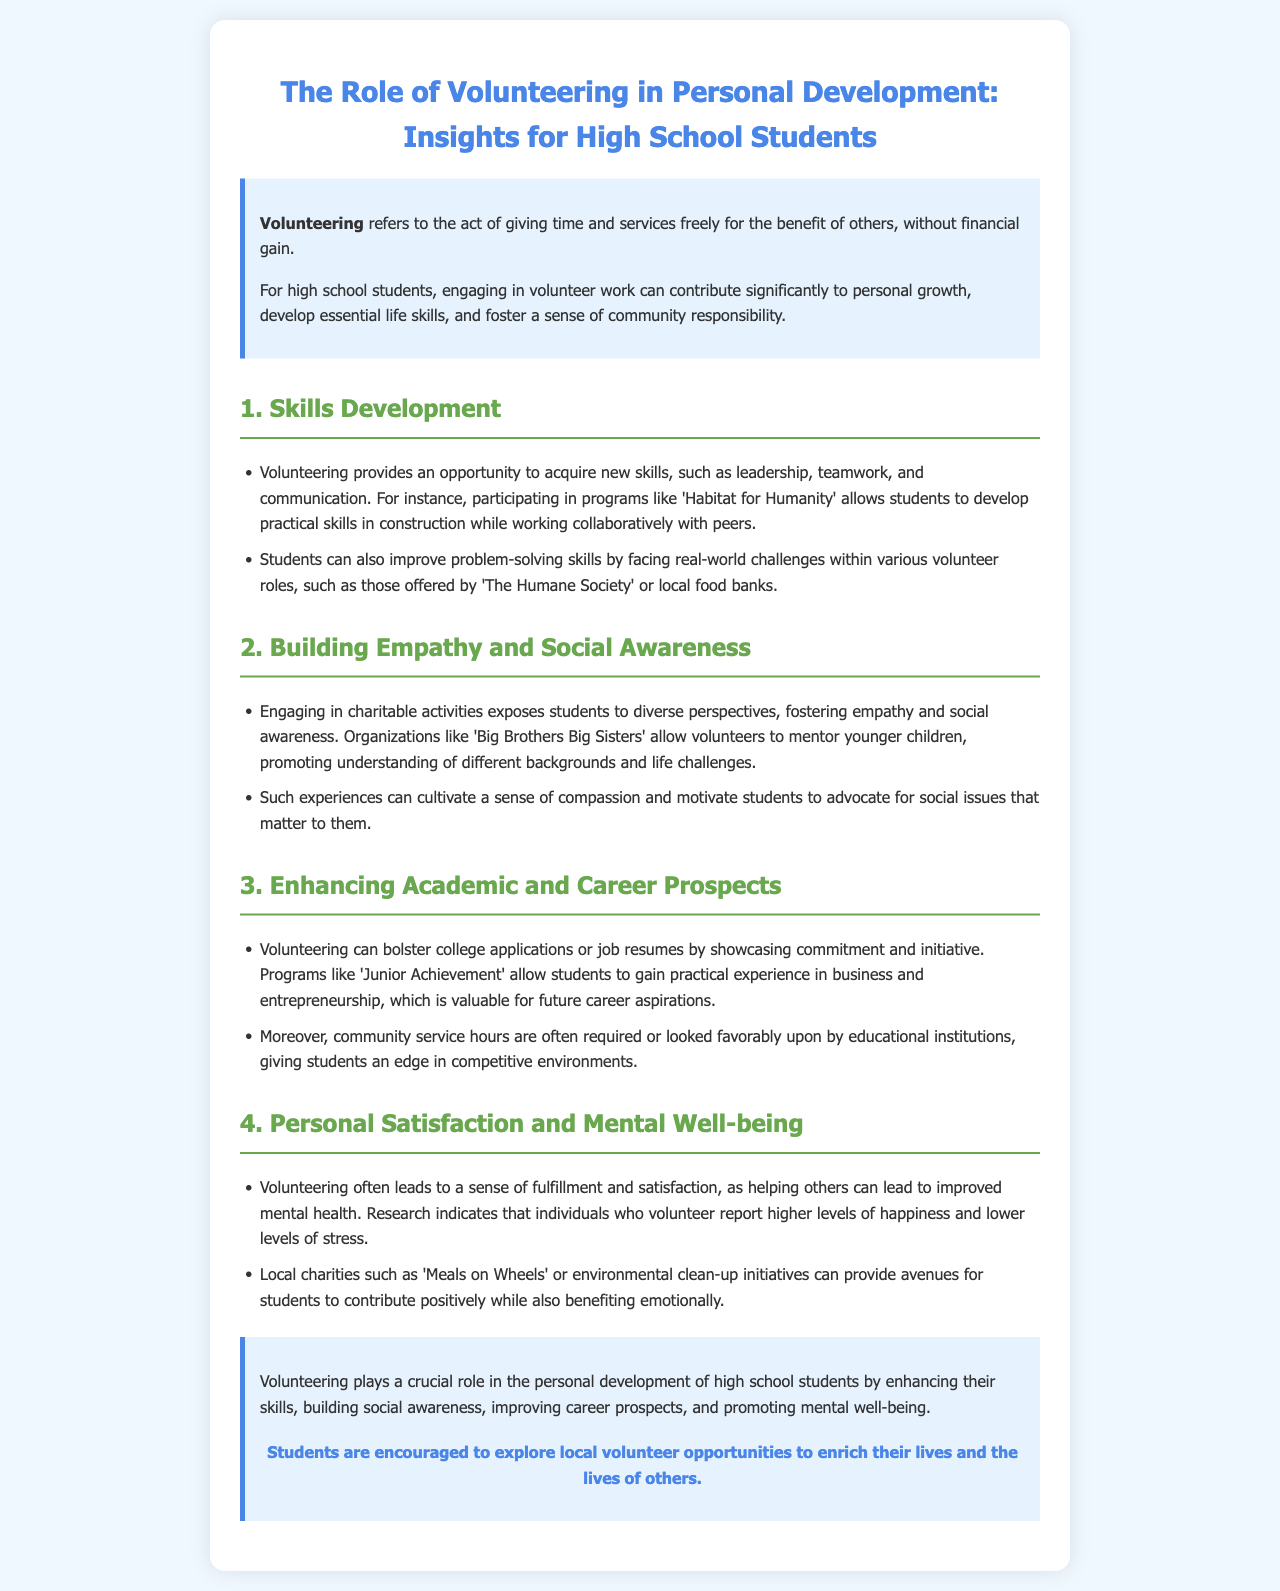What is the definition of volunteering? The definition is provided in the introduction of the document, stating that volunteering refers to the act of giving time and services freely for the benefit of others, without financial gain.
Answer: giving time and services freely What is one skill students can develop through volunteering? The document lists skills developed through volunteering, such as leadership, teamwork, and communication.
Answer: leadership Which organization allows students to mentor younger children? The document mentions 'Big Brothers Big Sisters' as an organization that allows volunteers to mentor younger children.
Answer: Big Brothers Big Sisters How can volunteering enhance career prospects? The document explains that volunteering can bolster college applications or job resumes by showcasing commitment and initiative.
Answer: showcases commitment and initiative What effect does volunteering have on mental health? The document states that volunteering can lead to improved mental health and individuals who volunteer report higher levels of happiness and lower levels of stress.
Answer: improved mental health What type of opportunities should students explore? The conclusion encourages students to explore local volunteer opportunities.
Answer: local volunteer opportunities Which organization provides practical experience in business and entrepreneurship? The document highlights 'Junior Achievement' as a program that provides practical experience in business and entrepreneurship.
Answer: Junior Achievement What is a key benefit of engaging in charitable activities? The document indicates that engaging in charitable activities fosters empathy and social awareness, which is a key benefit for students.
Answer: fosters empathy and social awareness How does volunteering contribute to personal growth? The document outlines various ways volunteering contributes to personal growth, including skills development and enhancing social awareness.
Answer: skills development, social awareness 